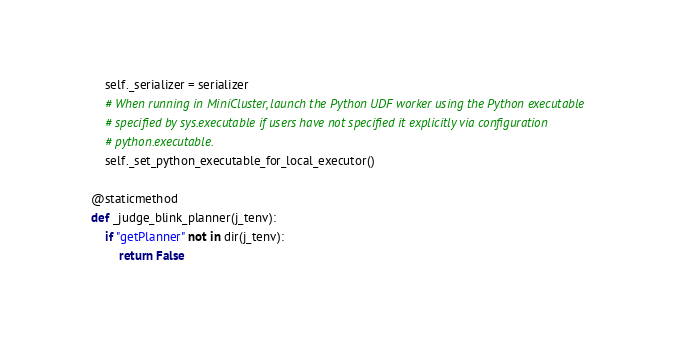<code> <loc_0><loc_0><loc_500><loc_500><_Python_>        self._serializer = serializer
        # When running in MiniCluster, launch the Python UDF worker using the Python executable
        # specified by sys.executable if users have not specified it explicitly via configuration
        # python.executable.
        self._set_python_executable_for_local_executor()

    @staticmethod
    def _judge_blink_planner(j_tenv):
        if "getPlanner" not in dir(j_tenv):
            return False</code> 